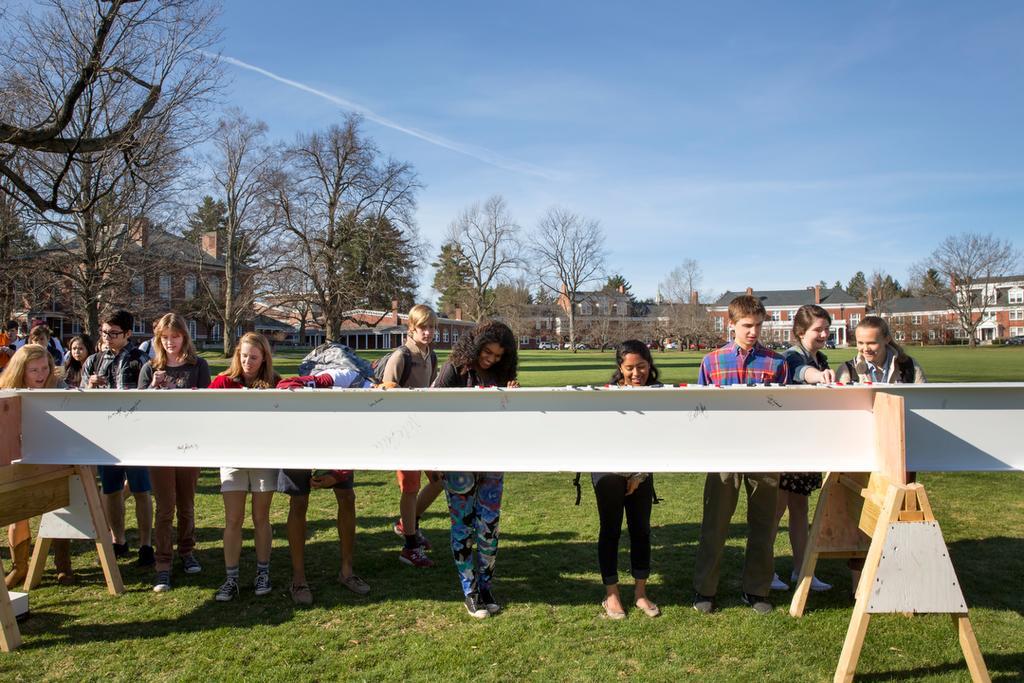Can you describe this image briefly? In this image there are a few people standing in front of the platform on the wooden stand. Behind them there are trees, buildings, cars. At the bottom of the image there is grass on the surface. At the top of the image there is sky. 